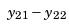Convert formula to latex. <formula><loc_0><loc_0><loc_500><loc_500>y _ { 2 1 } - y _ { 2 2 }</formula> 